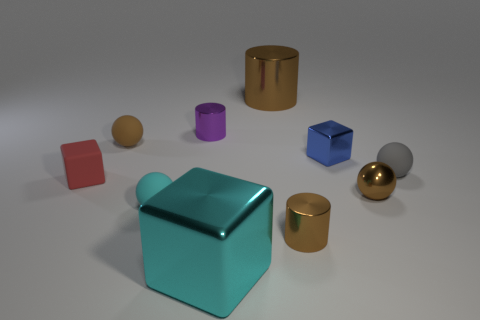Subtract all green spheres. Subtract all gray cylinders. How many spheres are left? 4 Subtract all cubes. How many objects are left? 7 Add 4 tiny cyan balls. How many tiny cyan balls are left? 5 Add 7 gray rubber balls. How many gray rubber balls exist? 8 Subtract 0 brown cubes. How many objects are left? 10 Subtract all large brown metallic things. Subtract all cyan rubber things. How many objects are left? 8 